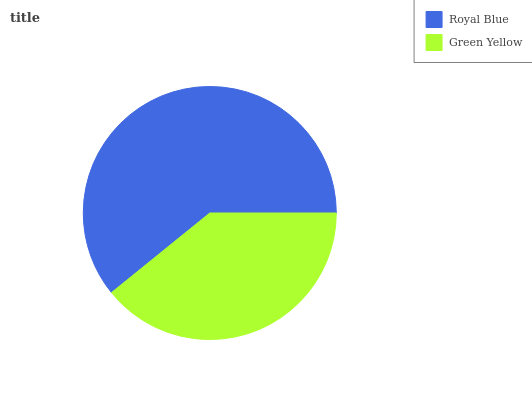Is Green Yellow the minimum?
Answer yes or no. Yes. Is Royal Blue the maximum?
Answer yes or no. Yes. Is Green Yellow the maximum?
Answer yes or no. No. Is Royal Blue greater than Green Yellow?
Answer yes or no. Yes. Is Green Yellow less than Royal Blue?
Answer yes or no. Yes. Is Green Yellow greater than Royal Blue?
Answer yes or no. No. Is Royal Blue less than Green Yellow?
Answer yes or no. No. Is Royal Blue the high median?
Answer yes or no. Yes. Is Green Yellow the low median?
Answer yes or no. Yes. Is Green Yellow the high median?
Answer yes or no. No. Is Royal Blue the low median?
Answer yes or no. No. 